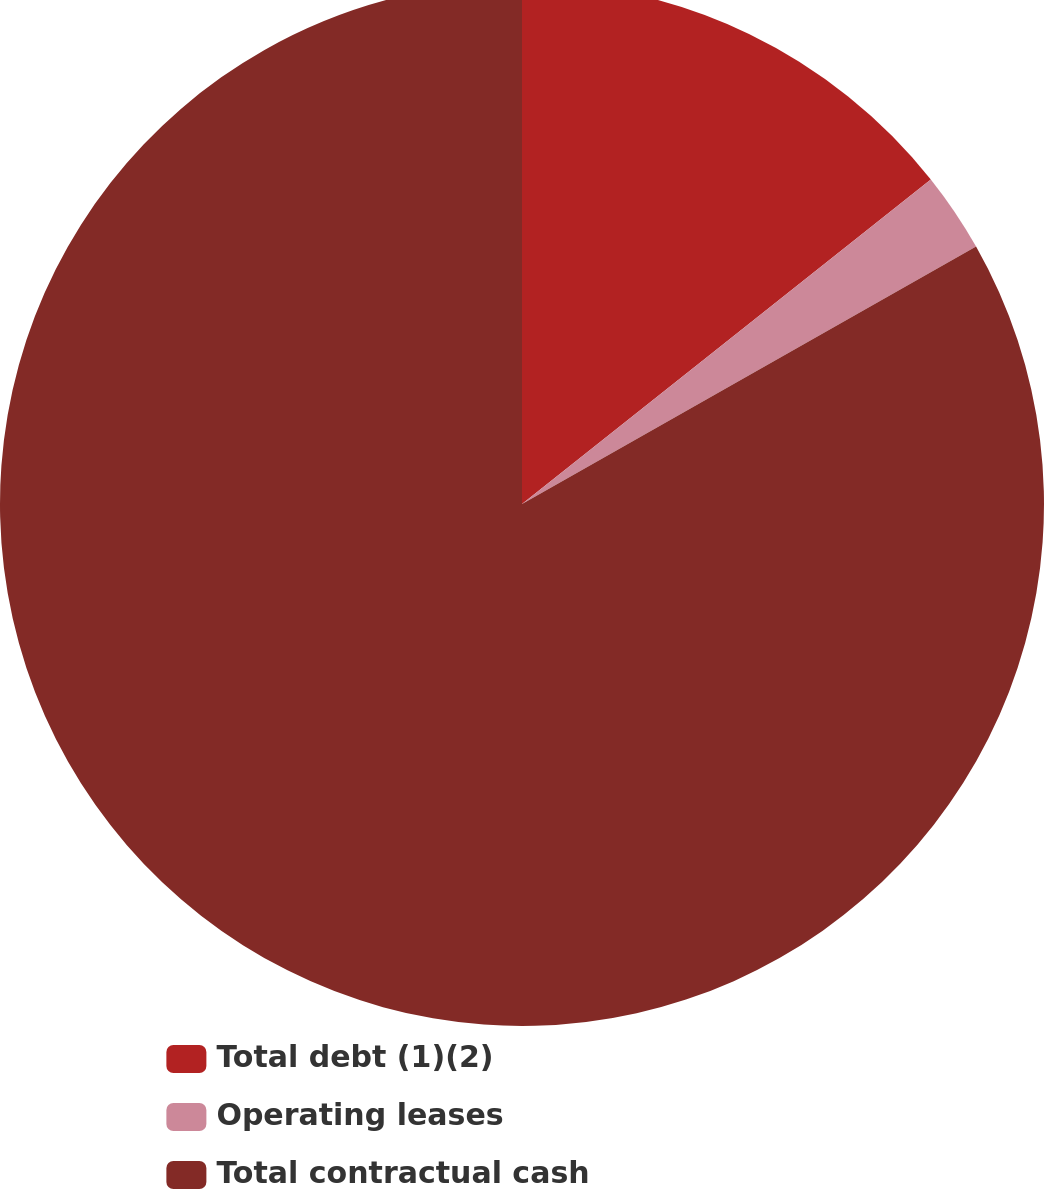Convert chart. <chart><loc_0><loc_0><loc_500><loc_500><pie_chart><fcel>Total debt (1)(2)<fcel>Operating leases<fcel>Total contractual cash<nl><fcel>14.32%<fcel>2.47%<fcel>83.21%<nl></chart> 